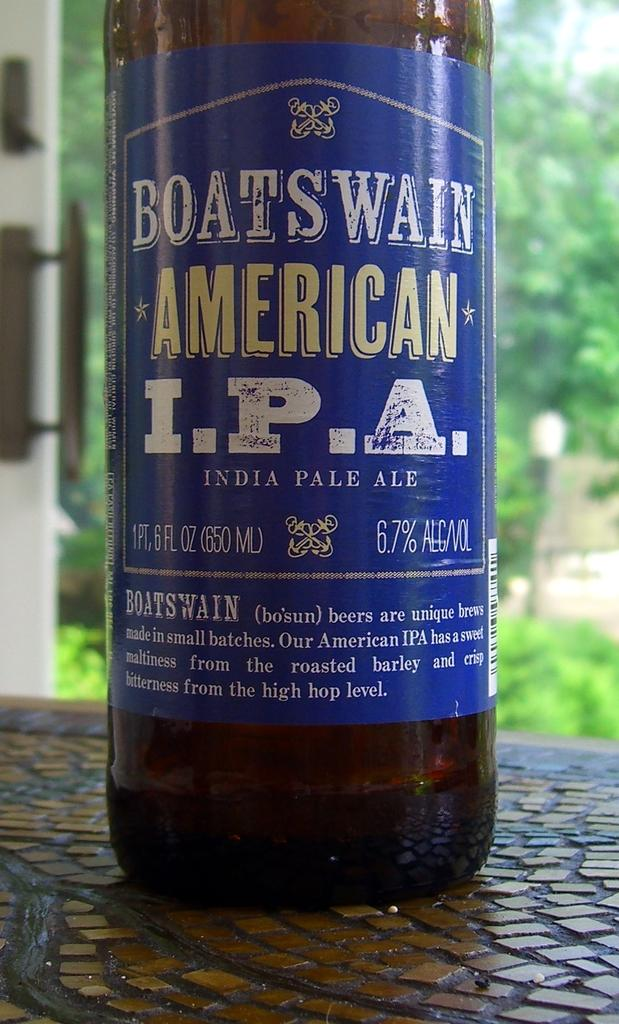What object is on the table in the image? There is a bottle on the table in the image. What type of natural element can be seen in the top right side of the image? There is a tree in the top right side of the image. Where is the closest needle shop to the tree in the image? There is no information about a needle shop or its location in the image. 